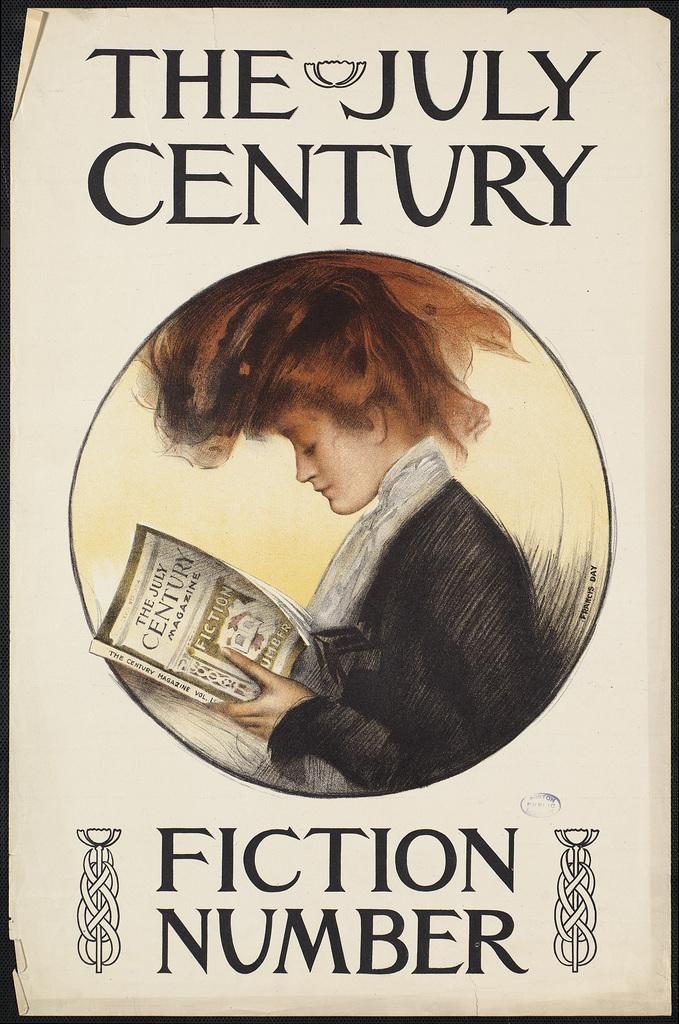<image>
Present a compact description of the photo's key features. An art print of the July Century Fiction Number 